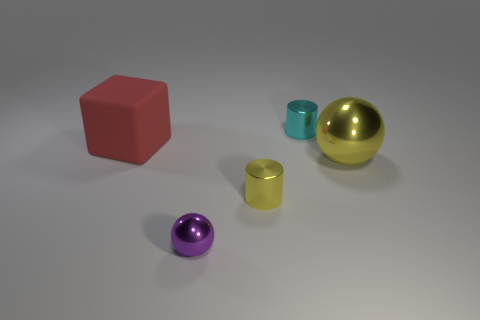Are there an equal number of large yellow objects that are to the right of the purple shiny object and large shiny balls that are right of the large yellow metallic thing?
Make the answer very short. No. What number of things are small cylinders or tiny objects that are behind the big metallic object?
Give a very brief answer. 2. There is a object that is both to the right of the tiny yellow cylinder and behind the large yellow thing; what shape is it?
Your response must be concise. Cylinder. There is a big object that is on the left side of the ball that is to the right of the purple shiny ball; what is its material?
Your answer should be compact. Rubber. Is the cylinder that is in front of the small cyan metal cylinder made of the same material as the cyan cylinder?
Give a very brief answer. Yes. There is a metal sphere that is behind the tiny metal ball; how big is it?
Provide a succinct answer. Large. There is a purple sphere in front of the large red matte block; is there a cyan thing that is in front of it?
Offer a very short reply. No. There is a small shiny cylinder in front of the red rubber block; is it the same color as the thing that is behind the red block?
Your response must be concise. No. The big ball is what color?
Give a very brief answer. Yellow. Is there any other thing that is the same color as the large metal object?
Your answer should be compact. Yes. 